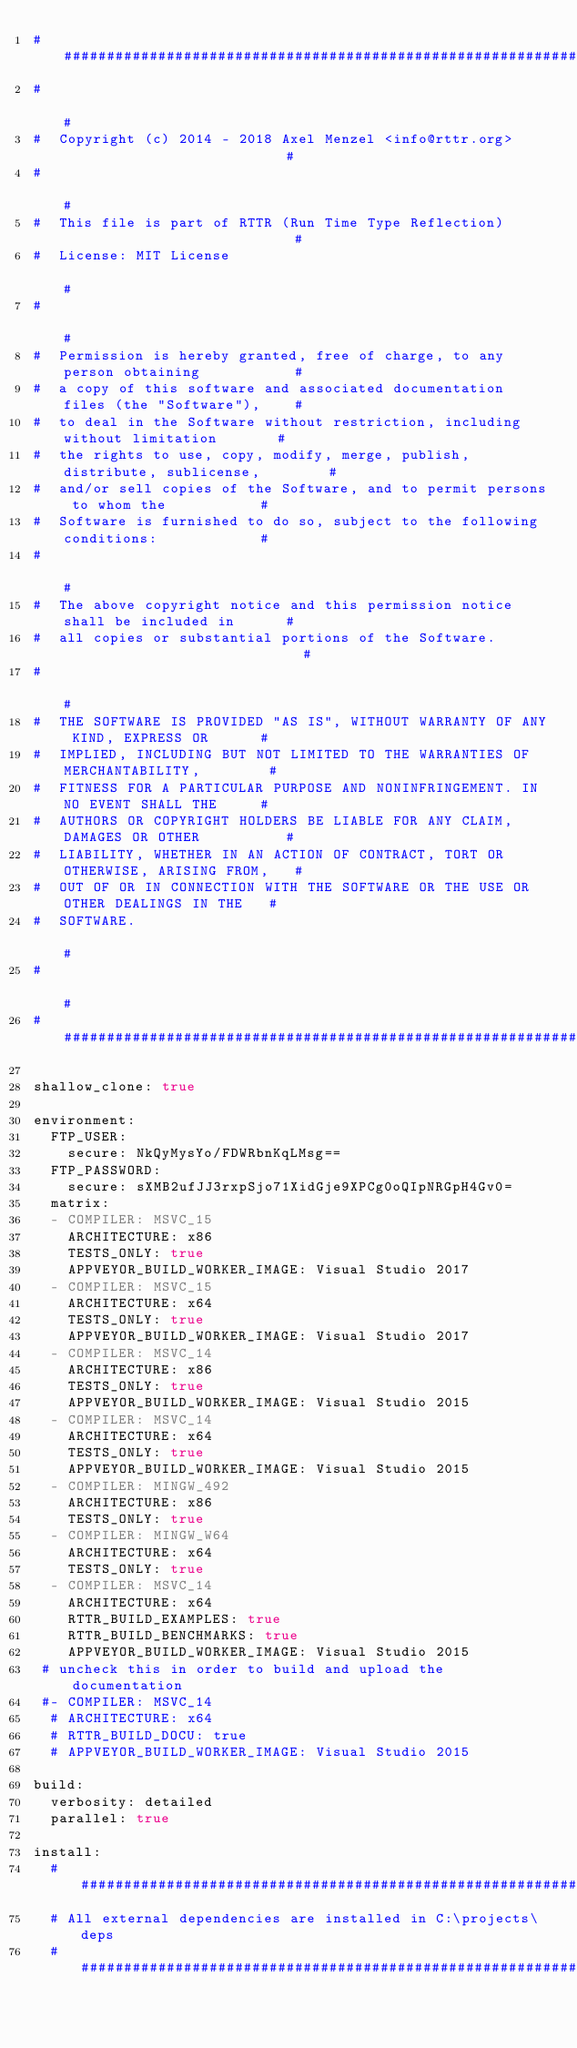Convert code to text. <code><loc_0><loc_0><loc_500><loc_500><_YAML_>####################################################################################
#                                                                                  #
#  Copyright (c) 2014 - 2018 Axel Menzel <info@rttr.org>                           #
#                                                                                  #
#  This file is part of RTTR (Run Time Type Reflection)                            #
#  License: MIT License                                                            #
#                                                                                  #
#  Permission is hereby granted, free of charge, to any person obtaining           #
#  a copy of this software and associated documentation files (the "Software"),    #
#  to deal in the Software without restriction, including without limitation       #
#  the rights to use, copy, modify, merge, publish, distribute, sublicense,        #
#  and/or sell copies of the Software, and to permit persons to whom the           #
#  Software is furnished to do so, subject to the following conditions:            #
#                                                                                  #
#  The above copyright notice and this permission notice shall be included in      #
#  all copies or substantial portions of the Software.                             #
#                                                                                  #
#  THE SOFTWARE IS PROVIDED "AS IS", WITHOUT WARRANTY OF ANY KIND, EXPRESS OR      #
#  IMPLIED, INCLUDING BUT NOT LIMITED TO THE WARRANTIES OF MERCHANTABILITY,        #
#  FITNESS FOR A PARTICULAR PURPOSE AND NONINFRINGEMENT. IN NO EVENT SHALL THE     #
#  AUTHORS OR COPYRIGHT HOLDERS BE LIABLE FOR ANY CLAIM, DAMAGES OR OTHER          #
#  LIABILITY, WHETHER IN AN ACTION OF CONTRACT, TORT OR OTHERWISE, ARISING FROM,   #
#  OUT OF OR IN CONNECTION WITH THE SOFTWARE OR THE USE OR OTHER DEALINGS IN THE   #
#  SOFTWARE.                                                                       #
#                                                                                  #
####################################################################################

shallow_clone: true

environment:
  FTP_USER:
    secure: NkQyMysYo/FDWRbnKqLMsg==
  FTP_PASSWORD:
    secure: sXMB2ufJJ3rxpSjo71XidGje9XPCg0oQIpNRGpH4Gv0=
  matrix:
  - COMPILER: MSVC_15
    ARCHITECTURE: x86
    TESTS_ONLY: true
    APPVEYOR_BUILD_WORKER_IMAGE: Visual Studio 2017
  - COMPILER: MSVC_15
    ARCHITECTURE: x64
    TESTS_ONLY: true
    APPVEYOR_BUILD_WORKER_IMAGE: Visual Studio 2017
  - COMPILER: MSVC_14
    ARCHITECTURE: x86
    TESTS_ONLY: true
    APPVEYOR_BUILD_WORKER_IMAGE: Visual Studio 2015
  - COMPILER: MSVC_14
    ARCHITECTURE: x64
    TESTS_ONLY: true
    APPVEYOR_BUILD_WORKER_IMAGE: Visual Studio 2015
  - COMPILER: MINGW_492
    ARCHITECTURE: x86
    TESTS_ONLY: true
  - COMPILER: MINGW_W64
    ARCHITECTURE: x64
    TESTS_ONLY: true
  - COMPILER: MSVC_14
    ARCHITECTURE: x64
    RTTR_BUILD_EXAMPLES: true
    RTTR_BUILD_BENCHMARKS: true
    APPVEYOR_BUILD_WORKER_IMAGE: Visual Studio 2015
 # uncheck this in order to build and upload the documentation
 #- COMPILER: MSVC_14
  # ARCHITECTURE: x64
  # RTTR_BUILD_DOCU: true
  # APPVEYOR_BUILD_WORKER_IMAGE: Visual Studio 2015

build:
  verbosity: detailed
  parallel: true

install:
  #######################################################################################
  # All external dependencies are installed in C:\projects\deps
  #######################################################################################</code> 